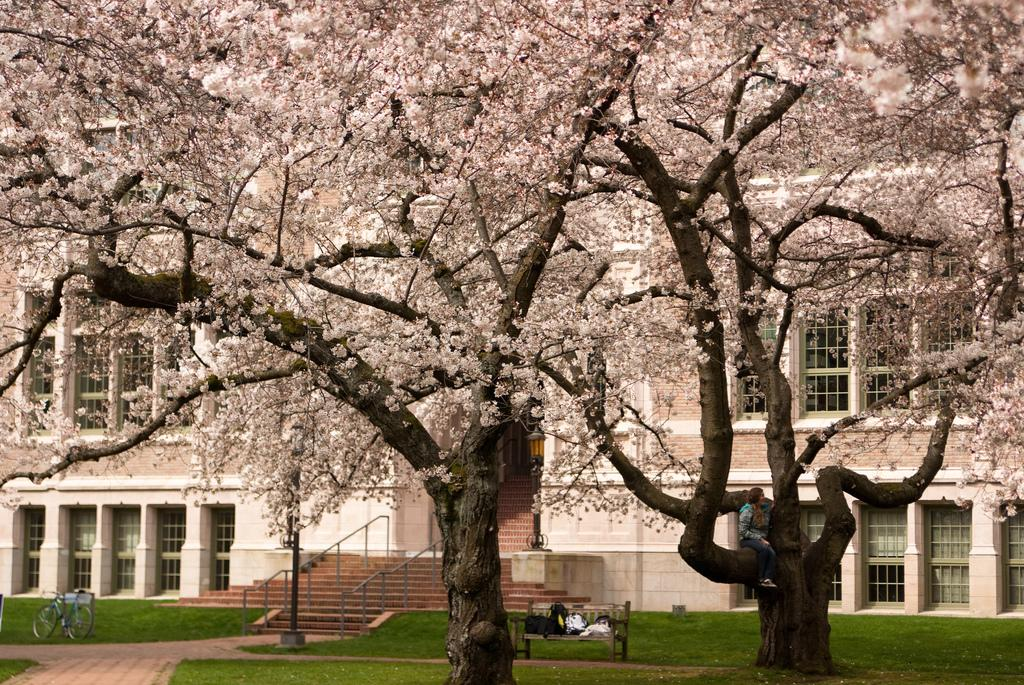What type of vegetation can be seen in the image? There are trees and grass in the image. What architectural feature is present in the image? There are stairs and railings in the image. What type of structure is visible in the image? There is a building with windows in the image. What type of seating is available in the image? There is a bench in the image. What mode of transportation is present in the image? There is a bicycle in the image. Is there a person in the image? Yes, a person is sitting in the image. What type of wool is being produced by the mine in the image? There is no mine or wool production present in the image. What type of disease is affecting the person sitting in the image? There is no indication of any disease affecting the person in the image. 